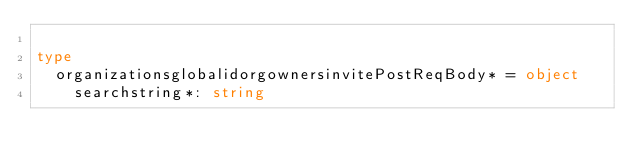Convert code to text. <code><loc_0><loc_0><loc_500><loc_500><_Nim_>
type
  organizationsglobalidorgownersinvitePostReqBody* = object
    searchstring*: string
</code> 